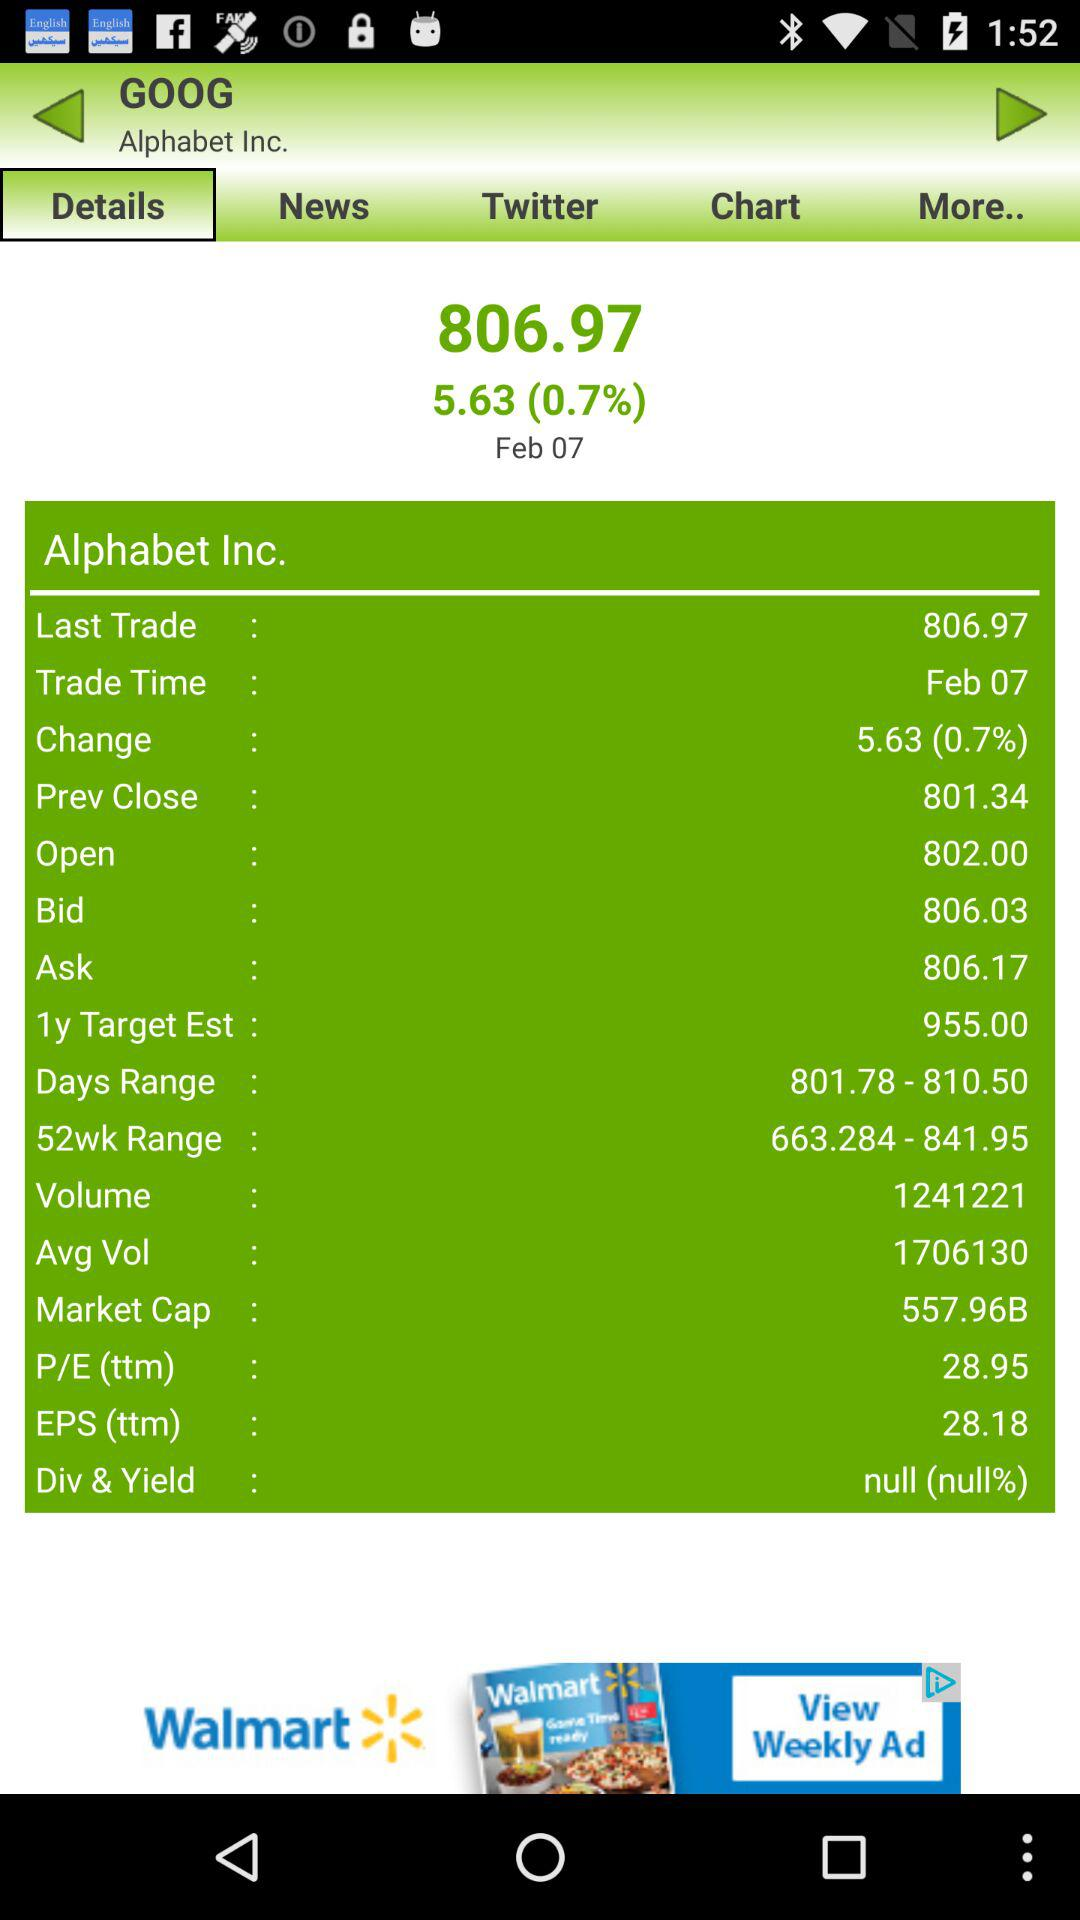Was the last trade time in the morning or the afternoon?
When the provided information is insufficient, respond with <no answer>. <no answer> 